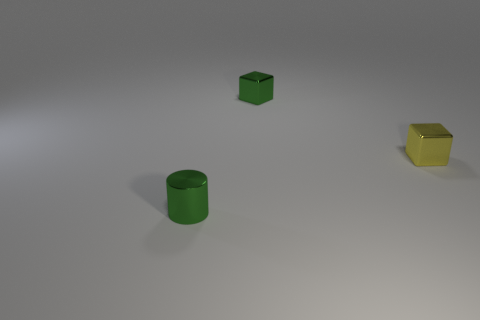Add 1 tiny cubes. How many objects exist? 4 Subtract all blocks. How many objects are left? 1 Subtract 1 blocks. How many blocks are left? 1 Add 2 shiny cylinders. How many shiny cylinders exist? 3 Subtract 0 red cubes. How many objects are left? 3 Subtract all cyan cubes. Subtract all purple cylinders. How many cubes are left? 2 Subtract all purple cylinders. How many purple cubes are left? 0 Subtract all large brown rubber spheres. Subtract all green metallic things. How many objects are left? 1 Add 3 tiny shiny cylinders. How many tiny shiny cylinders are left? 4 